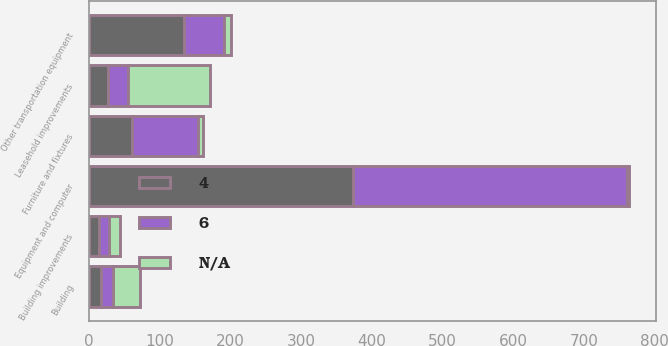Convert chart. <chart><loc_0><loc_0><loc_500><loc_500><stacked_bar_chart><ecel><fcel>Building<fcel>Building improvements<fcel>Leasehold improvements<fcel>Equipment and computer<fcel>Other transportation equipment<fcel>Furniture and fixtures<nl><fcel>nan<fcel>39<fcel>15<fcel>115<fcel>3<fcel>10<fcel>7<nl><fcel>4<fcel>17<fcel>15<fcel>28<fcel>374<fcel>135<fcel>62<nl><fcel>6<fcel>17<fcel>14<fcel>28<fcel>387<fcel>56<fcel>93<nl></chart> 